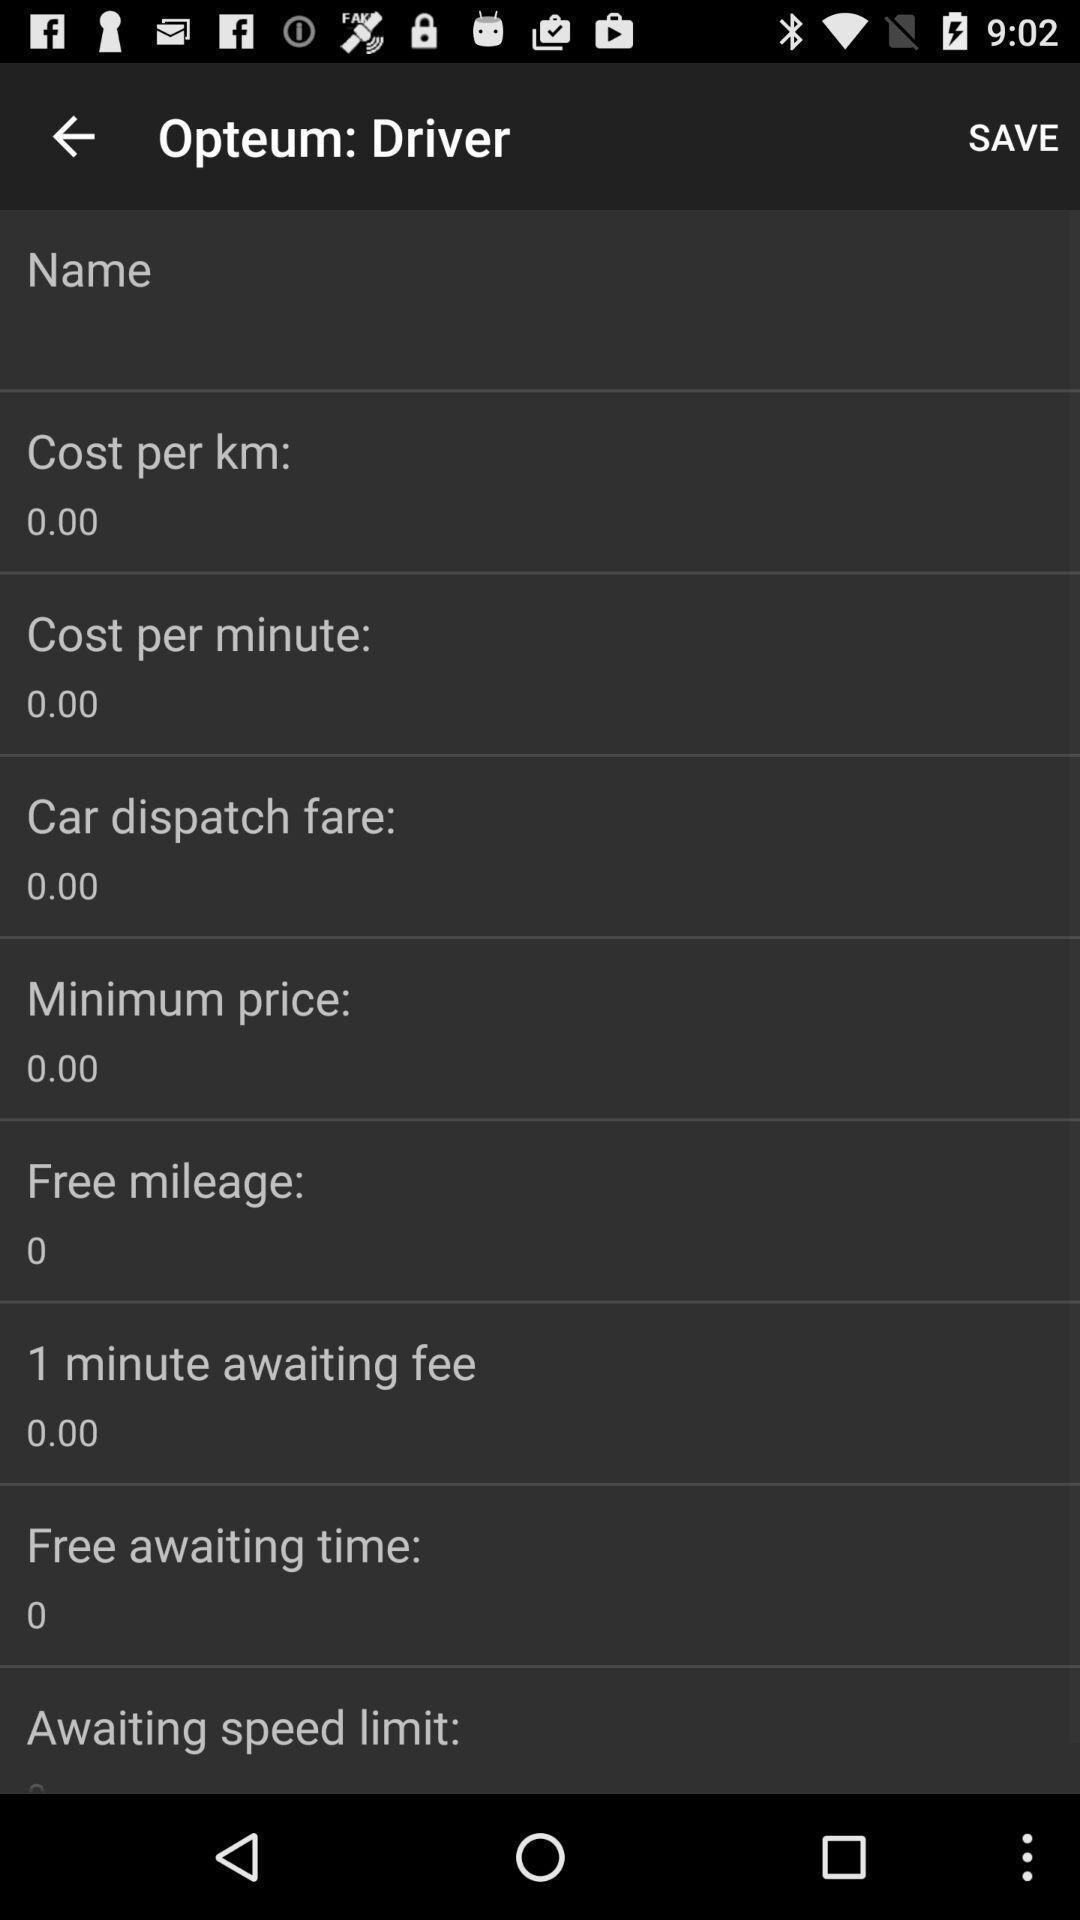Describe the visual elements of this screenshot. Screen displaying multiple information of a vehicle. 